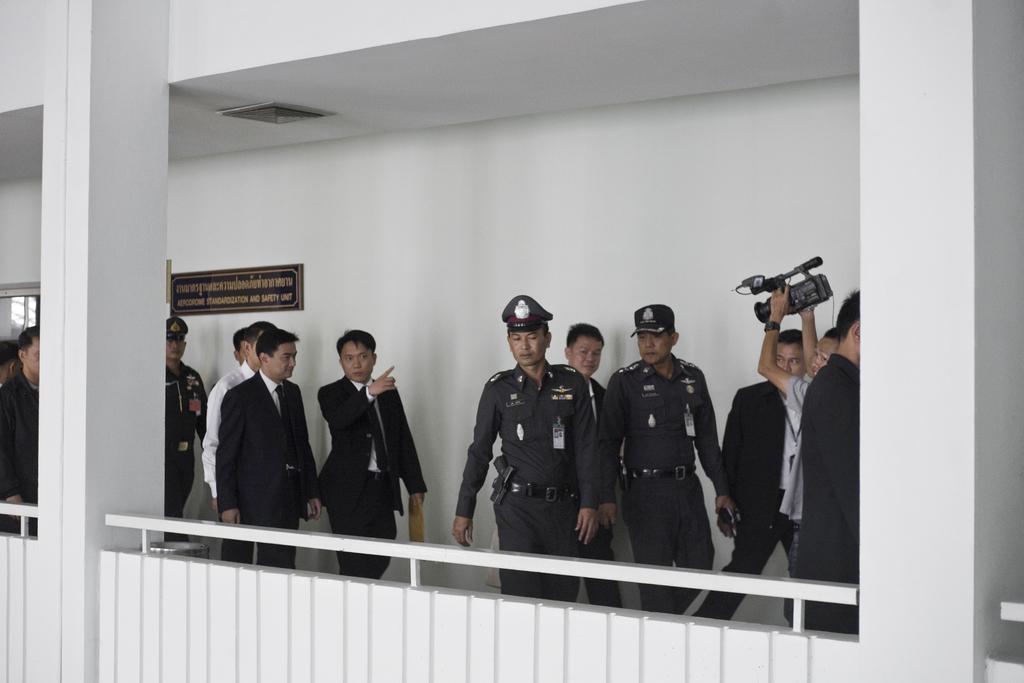Please provide a concise description of this image. In this picture we can see a group of people, pillars, fence and a person holding a camera with hands and in the background we can see a name board on the wall and some objects. 